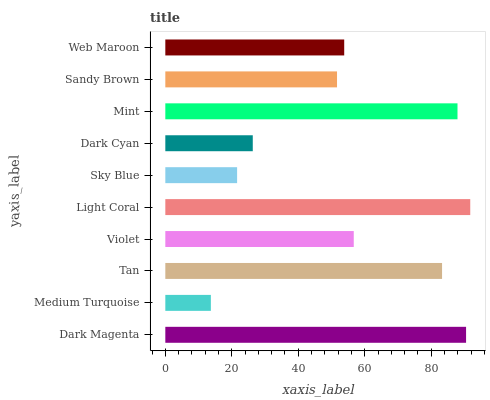Is Medium Turquoise the minimum?
Answer yes or no. Yes. Is Light Coral the maximum?
Answer yes or no. Yes. Is Tan the minimum?
Answer yes or no. No. Is Tan the maximum?
Answer yes or no. No. Is Tan greater than Medium Turquoise?
Answer yes or no. Yes. Is Medium Turquoise less than Tan?
Answer yes or no. Yes. Is Medium Turquoise greater than Tan?
Answer yes or no. No. Is Tan less than Medium Turquoise?
Answer yes or no. No. Is Violet the high median?
Answer yes or no. Yes. Is Web Maroon the low median?
Answer yes or no. Yes. Is Light Coral the high median?
Answer yes or no. No. Is Dark Magenta the low median?
Answer yes or no. No. 